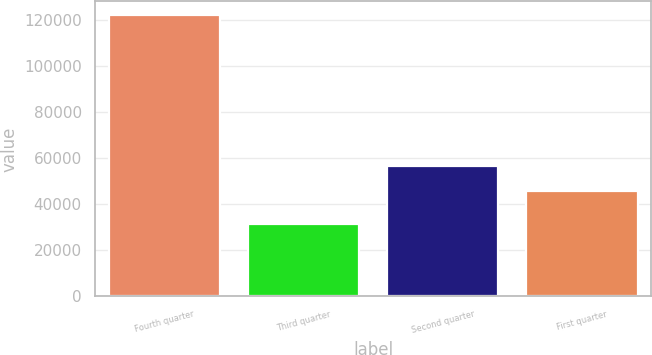<chart> <loc_0><loc_0><loc_500><loc_500><bar_chart><fcel>Fourth quarter<fcel>Third quarter<fcel>Second quarter<fcel>First quarter<nl><fcel>121802<fcel>31231<fcel>56400<fcel>45704<nl></chart> 